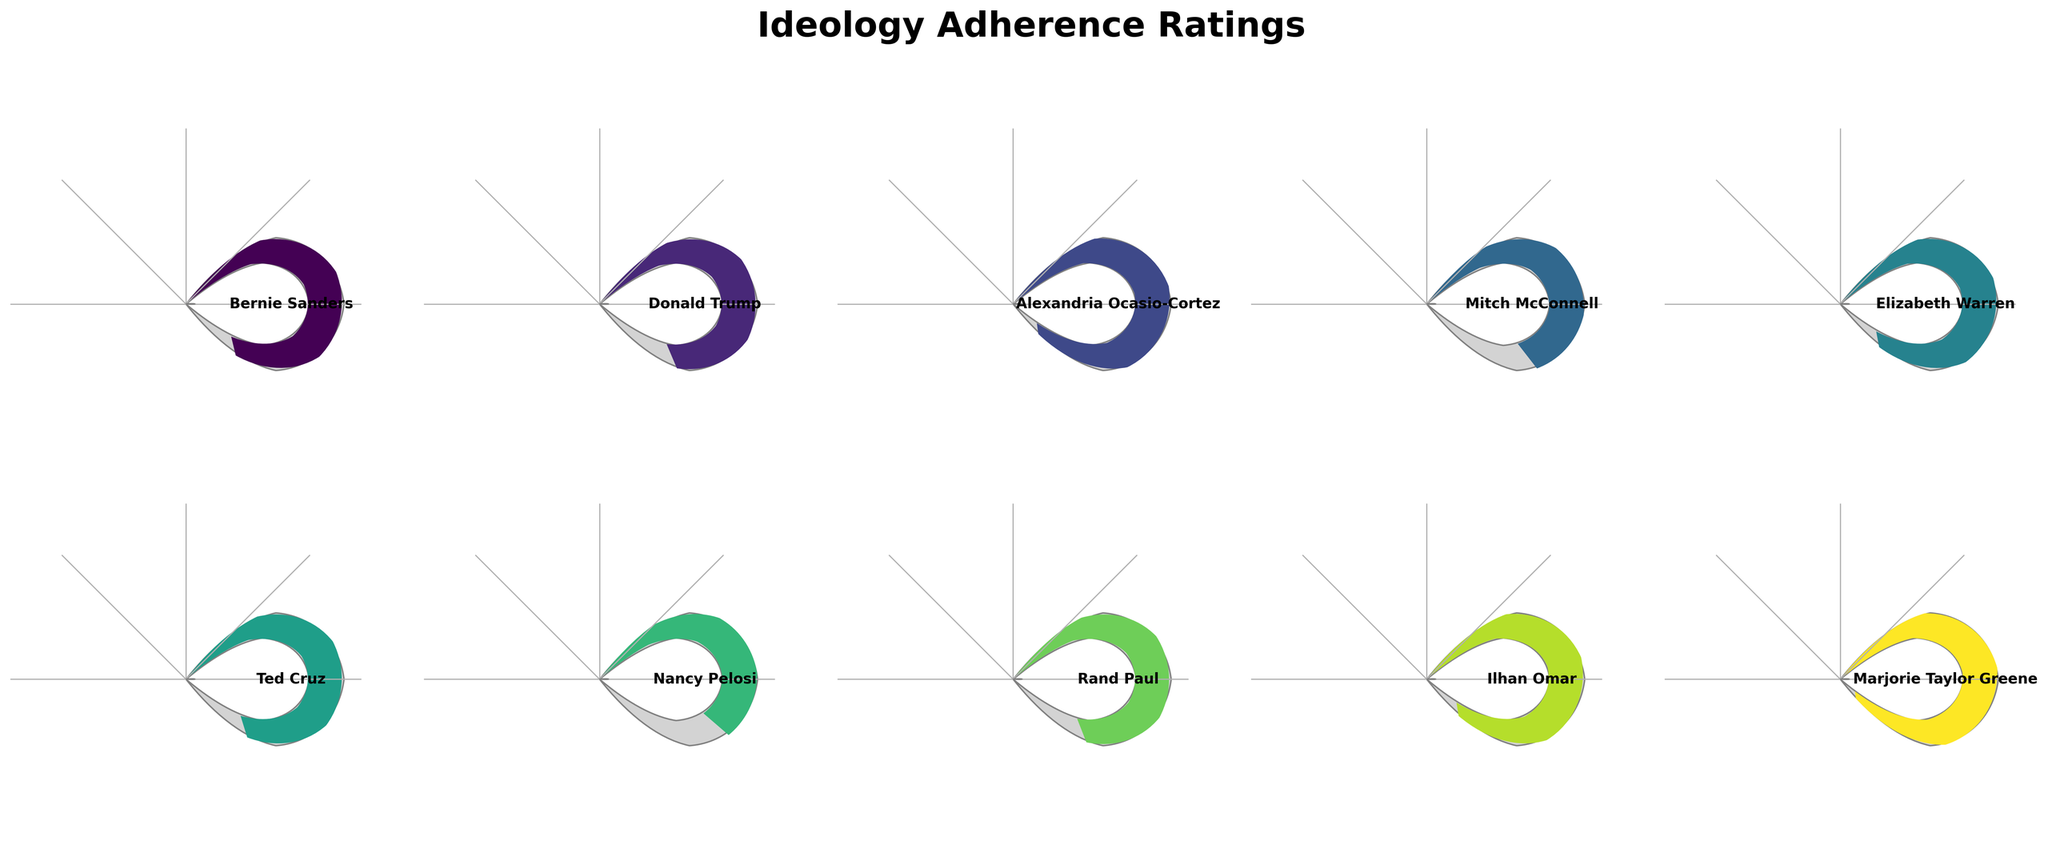What is the title of the figure? The title of the figure is displayed at the top and it reads "Ideology Adherence Ratings".
Answer: Ideology Adherence Ratings How many politicians are represented in the figure? By counting the individual gauge charts, we can see there are 10 politicians represented in the figure.
Answer: 10 Which politician has the highest adherence rating? The figure shows a gauge for each politician, with Marjorie Taylor Greene having the needle pointing to the highest rating at 95.
Answer: Marjorie Taylor Greene What is the adherence rating of Rand Paul? Looking at the gauge labelled "Rand Paul", the needle points to a rating of 79.
Answer: 79 Which politician has the lowest adherence rating? Among all the gauges, Nancy Pelosi's rating is the lowest, with the needle pointing to 65.
Answer: Nancy Pelosi What is the average adherence rating of all the politicians? Sum of all adherence ratings (85 + 78 + 92 + 70 + 88 + 82 + 65 + 79 + 90 + 95) = 824. Divide by the number of politicians, 824 / 10 = 82.4.
Answer: 82.4 What is the difference in adherence ratings between Alexandria Ocasio-Cortez and Mitch McConnell? Alexandria Ocasio-Cortez has a rating of 92, and Mitch McConnell has a rating of 70. The difference is 92 - 70 = 22.
Answer: 22 Which politicians have an adherence rating of over 90? By inspecting the figure, Alexandria Ocasio-Cortez (92), Ilhan Omar (90), and Marjorie Taylor Greene (95) all have ratings over 90.
Answer: Alexandria Ocasio-Cortez, Ilhan Omar, Marjorie Taylor Greene How many politicians have an adherence rating between 70 and 80? Politicians with ratings in this range are Donald Trump (78), Mitch McConnell (70), and Rand Paul (79). This is a total of 3 politicians.
Answer: 3 What is the median adherence rating? Listing the ratings in ascending order: 65, 70, 78, 79, 82, 85, 88, 90, 92, 95, the median (middle) value in the sorted list of 10 values is the average of the 5th and 6th values: (82 + 85) / 2 = 83.5.
Answer: 83.5 